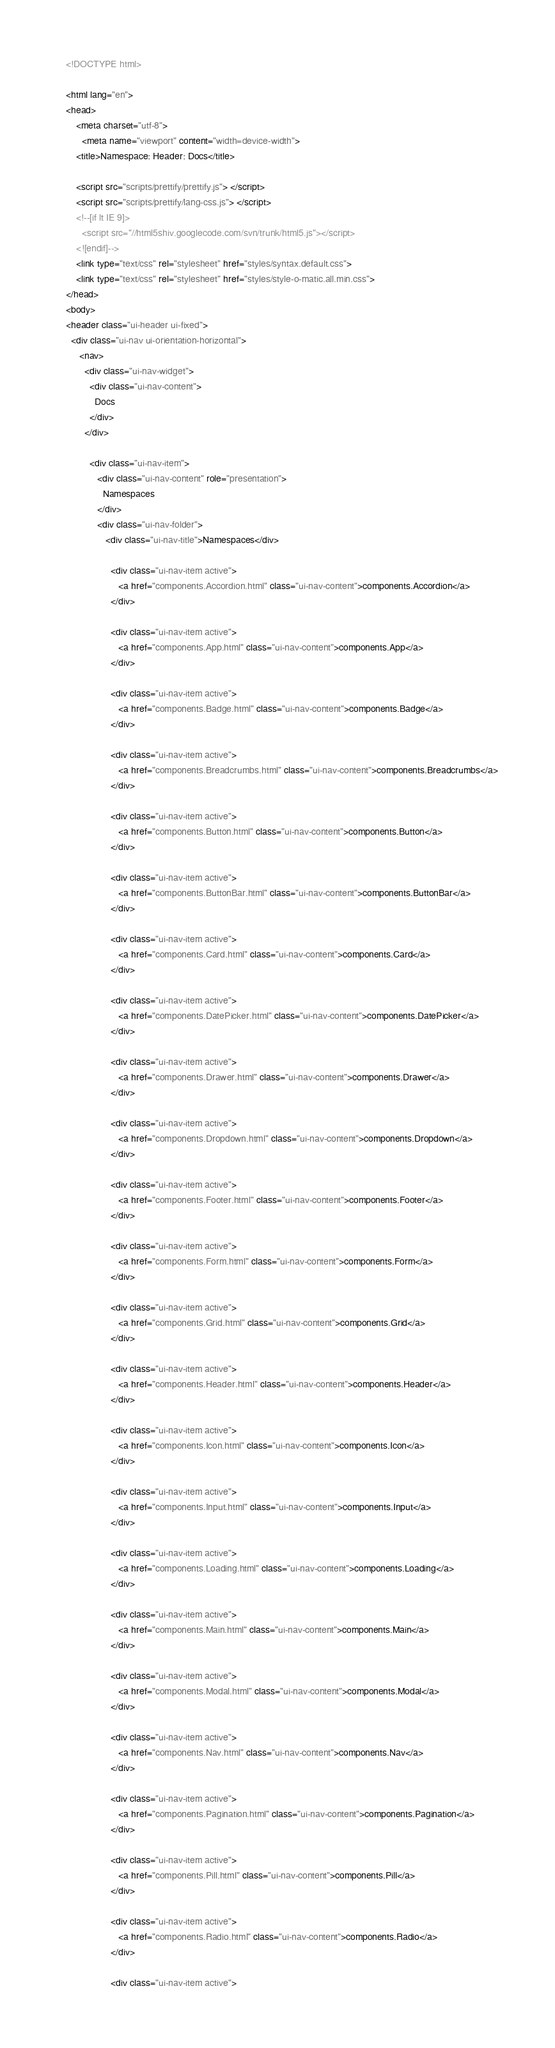Convert code to text. <code><loc_0><loc_0><loc_500><loc_500><_HTML_><!DOCTYPE html>

<html lang="en">
<head>
    <meta charset="utf-8">
	  <meta name="viewport" content="width=device-width">
    <title>Namespace: Header: Docs</title>

    <script src="scripts/prettify/prettify.js"> </script>
    <script src="scripts/prettify/lang-css.js"> </script>
    <!--[if lt IE 9]>
      <script src="//html5shiv.googlecode.com/svn/trunk/html5.js"></script>
    <![endif]-->
    <link type="text/css" rel="stylesheet" href="styles/syntax.default.css">
    <link type="text/css" rel="stylesheet" href="styles/style-o-matic.all.min.css">
</head>
<body>
<header class="ui-header ui-fixed">
  <div class="ui-nav ui-orientation-horizontal">
     <nav>
       <div class="ui-nav-widget">
         <div class="ui-nav-content">
           Docs
         </div>
       </div>
       
         <div class="ui-nav-item">
            <div class="ui-nav-content" role="presentation">
              Namespaces
            </div>
            <div class="ui-nav-folder">
               <div class="ui-nav-title">Namespaces</div>
               
                 <div class="ui-nav-item active">
                    <a href="components.Accordion.html" class="ui-nav-content">components.Accordion</a>
                 </div>
               
                 <div class="ui-nav-item active">
                    <a href="components.App.html" class="ui-nav-content">components.App</a>
                 </div>
               
                 <div class="ui-nav-item active">
                    <a href="components.Badge.html" class="ui-nav-content">components.Badge</a>
                 </div>
               
                 <div class="ui-nav-item active">
                    <a href="components.Breadcrumbs.html" class="ui-nav-content">components.Breadcrumbs</a>
                 </div>
               
                 <div class="ui-nav-item active">
                    <a href="components.Button.html" class="ui-nav-content">components.Button</a>
                 </div>
               
                 <div class="ui-nav-item active">
                    <a href="components.ButtonBar.html" class="ui-nav-content">components.ButtonBar</a>
                 </div>
               
                 <div class="ui-nav-item active">
                    <a href="components.Card.html" class="ui-nav-content">components.Card</a>
                 </div>
               
                 <div class="ui-nav-item active">
                    <a href="components.DatePicker.html" class="ui-nav-content">components.DatePicker</a>
                 </div>
               
                 <div class="ui-nav-item active">
                    <a href="components.Drawer.html" class="ui-nav-content">components.Drawer</a>
                 </div>
               
                 <div class="ui-nav-item active">
                    <a href="components.Dropdown.html" class="ui-nav-content">components.Dropdown</a>
                 </div>
               
                 <div class="ui-nav-item active">
                    <a href="components.Footer.html" class="ui-nav-content">components.Footer</a>
                 </div>
               
                 <div class="ui-nav-item active">
                    <a href="components.Form.html" class="ui-nav-content">components.Form</a>
                 </div>
               
                 <div class="ui-nav-item active">
                    <a href="components.Grid.html" class="ui-nav-content">components.Grid</a>
                 </div>
               
                 <div class="ui-nav-item active">
                    <a href="components.Header.html" class="ui-nav-content">components.Header</a>
                 </div>
               
                 <div class="ui-nav-item active">
                    <a href="components.Icon.html" class="ui-nav-content">components.Icon</a>
                 </div>
               
                 <div class="ui-nav-item active">
                    <a href="components.Input.html" class="ui-nav-content">components.Input</a>
                 </div>
               
                 <div class="ui-nav-item active">
                    <a href="components.Loading.html" class="ui-nav-content">components.Loading</a>
                 </div>
               
                 <div class="ui-nav-item active">
                    <a href="components.Main.html" class="ui-nav-content">components.Main</a>
                 </div>
               
                 <div class="ui-nav-item active">
                    <a href="components.Modal.html" class="ui-nav-content">components.Modal</a>
                 </div>
               
                 <div class="ui-nav-item active">
                    <a href="components.Nav.html" class="ui-nav-content">components.Nav</a>
                 </div>
               
                 <div class="ui-nav-item active">
                    <a href="components.Pagination.html" class="ui-nav-content">components.Pagination</a>
                 </div>
               
                 <div class="ui-nav-item active">
                    <a href="components.Pill.html" class="ui-nav-content">components.Pill</a>
                 </div>
               
                 <div class="ui-nav-item active">
                    <a href="components.Radio.html" class="ui-nav-content">components.Radio</a>
                 </div>
               
                 <div class="ui-nav-item active"></code> 